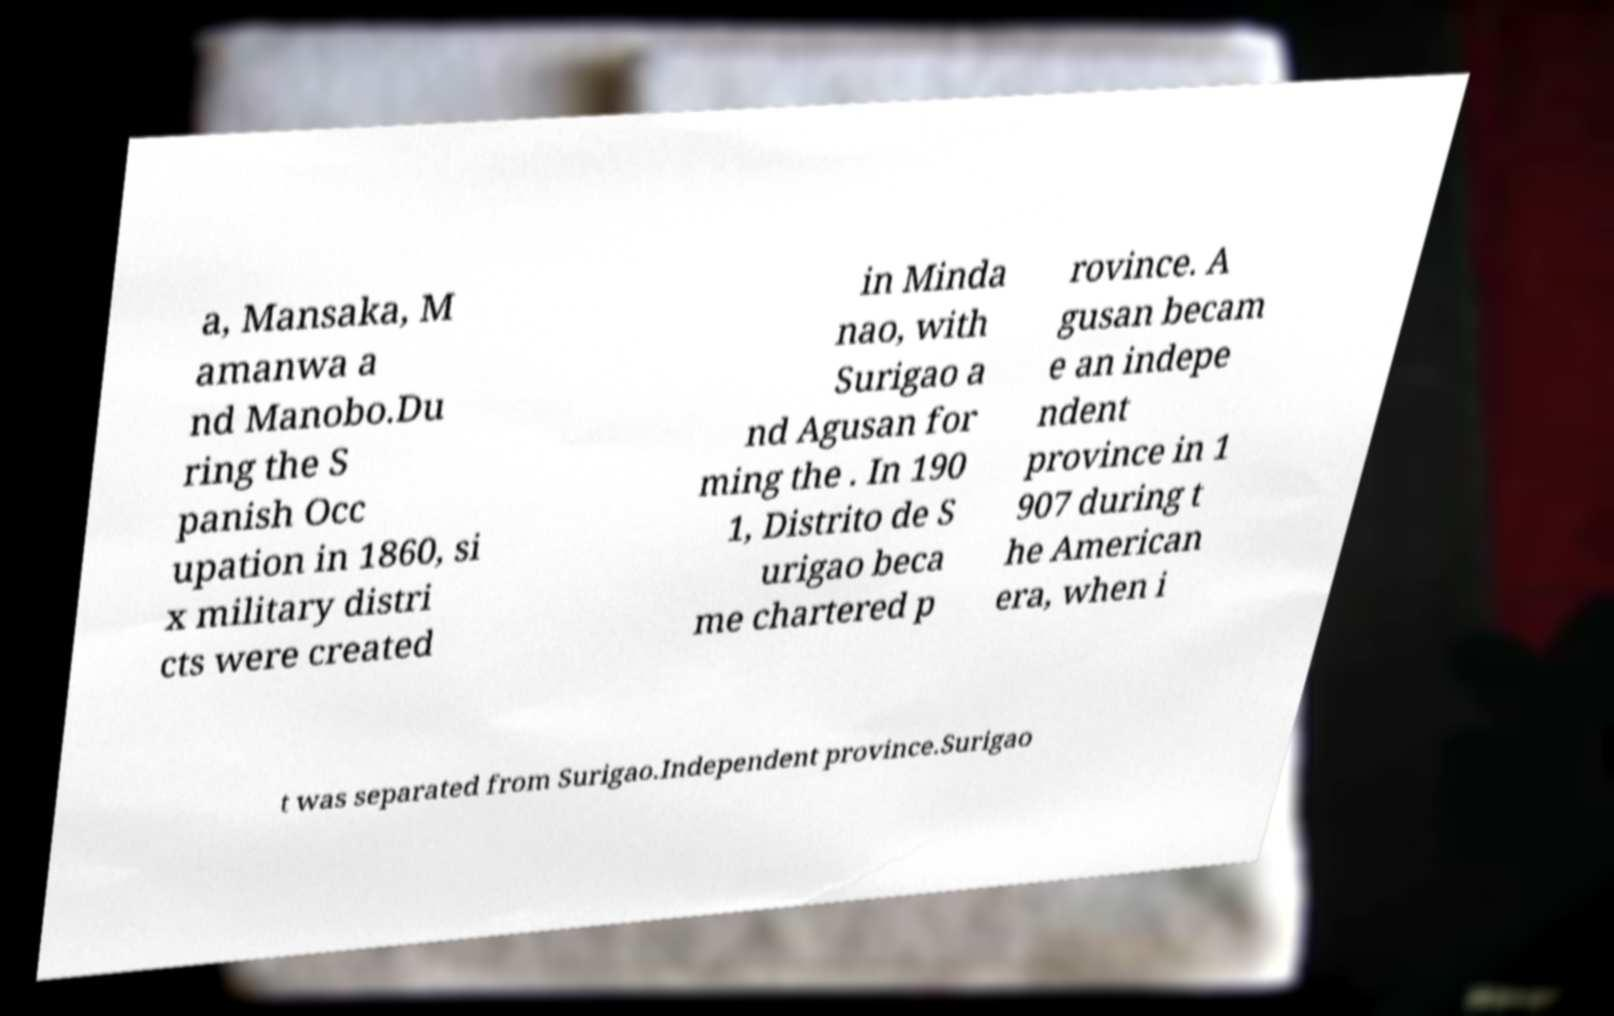For documentation purposes, I need the text within this image transcribed. Could you provide that? a, Mansaka, M amanwa a nd Manobo.Du ring the S panish Occ upation in 1860, si x military distri cts were created in Minda nao, with Surigao a nd Agusan for ming the . In 190 1, Distrito de S urigao beca me chartered p rovince. A gusan becam e an indepe ndent province in 1 907 during t he American era, when i t was separated from Surigao.Independent province.Surigao 